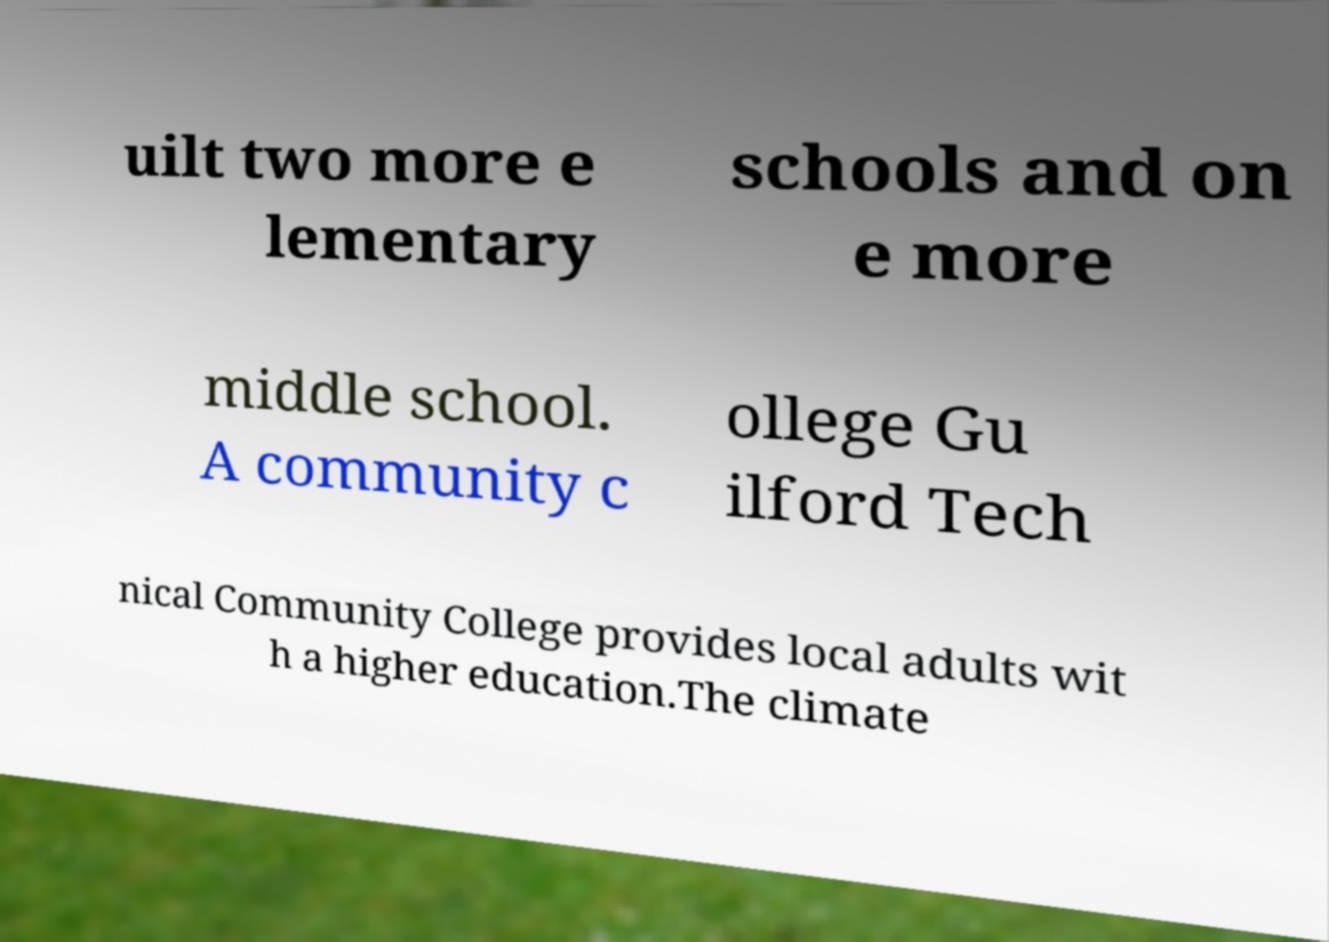Please read and relay the text visible in this image. What does it say? uilt two more e lementary schools and on e more middle school. A community c ollege Gu ilford Tech nical Community College provides local adults wit h a higher education.The climate 